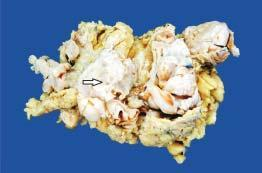does large cystic spaces lined by the flattened endothelial cells and containing lymph show replacement of almost whole breast with a large circumscribed, greywhite, firm, nodular mass having slit-like, compressed cystic areas and areas of haemorrhage?
Answer the question using a single word or phrase. No 